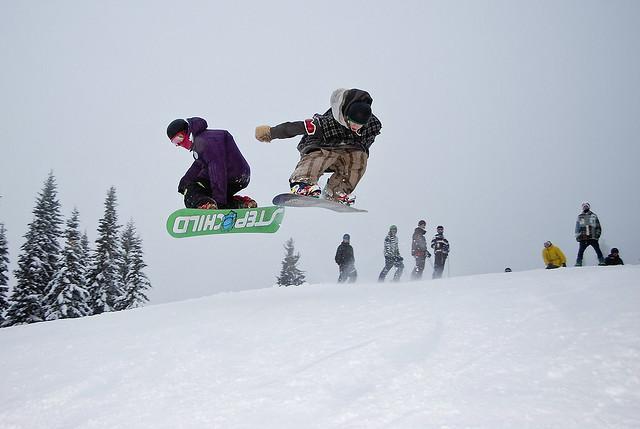Which famous person fits the description on the bottom of the board?
Choose the right answer from the provided options to respond to the question.
Options: Liberace, amy smart, jessica biel, zoe kravitz. Zoe kravitz. 